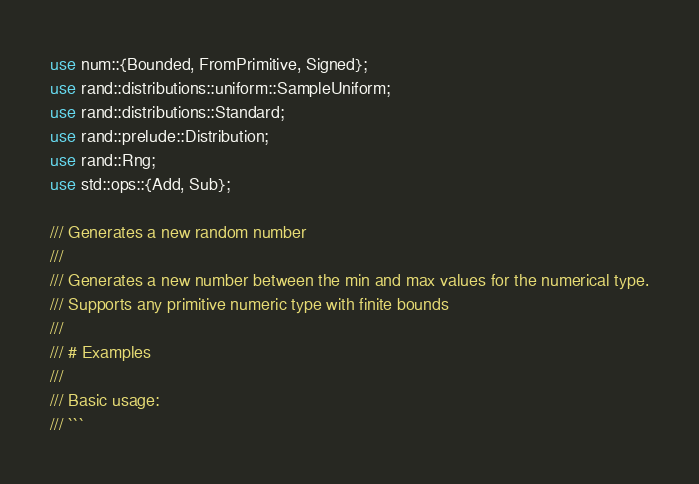<code> <loc_0><loc_0><loc_500><loc_500><_Rust_>use num::{Bounded, FromPrimitive, Signed};
use rand::distributions::uniform::SampleUniform;
use rand::distributions::Standard;
use rand::prelude::Distribution;
use rand::Rng;
use std::ops::{Add, Sub};

/// Generates a new random number
///
/// Generates a new number between the min and max values for the numerical type.
/// Supports any primitive numeric type with finite bounds
///
/// # Examples
///
/// Basic usage:
/// ```</code> 